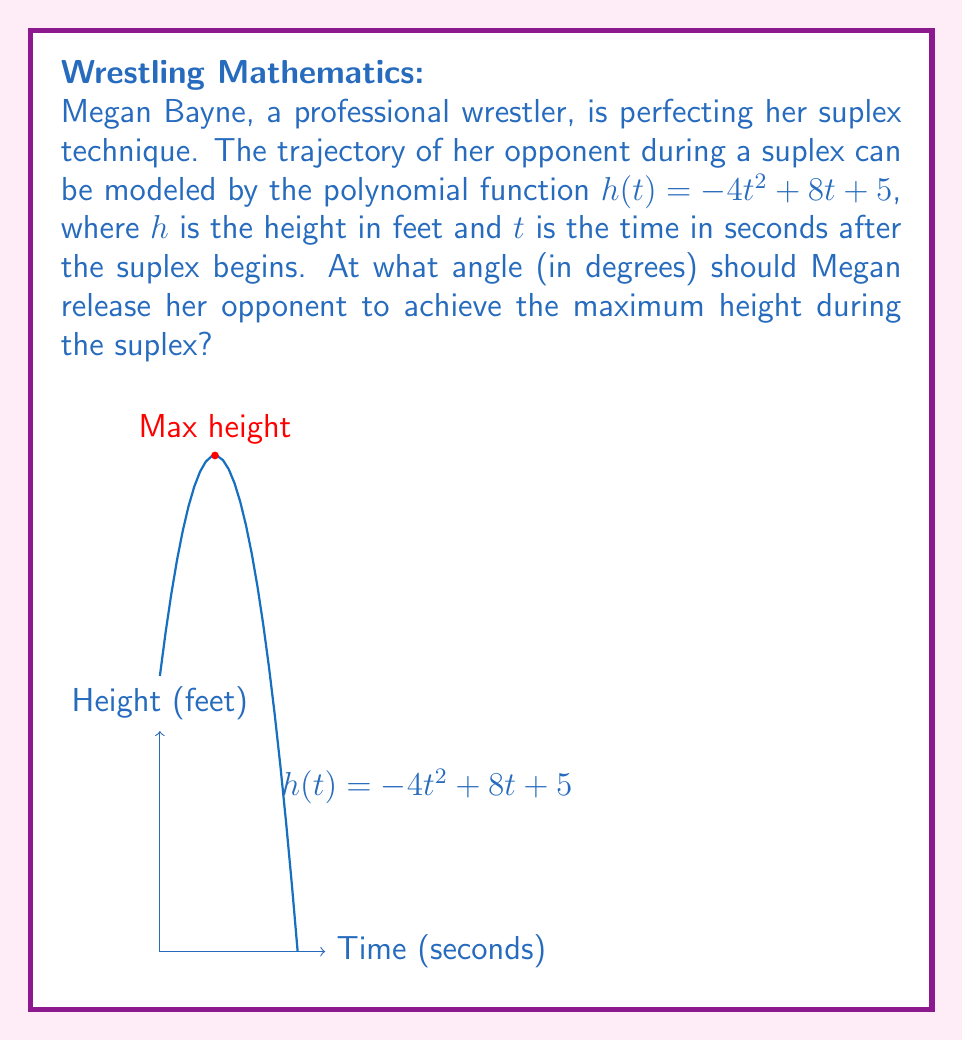Teach me how to tackle this problem. Let's approach this step-by-step:

1) To find the maximum height, we need to find the vertex of the parabola described by $h(t) = -4t^2 + 8t + 5$.

2) For a quadratic function in the form $f(x) = ax^2 + bx + c$, the x-coordinate of the vertex is given by $x = -\frac{b}{2a}$.

3) In our case, $a = -4$ and $b = 8$. So:

   $t = -\frac{8}{2(-4)} = -\frac{8}{-8} = 1$ second

4) This means the maximum height occurs 1 second after the suplex begins.

5) To find the angle, we need to use the derivative of $h(t)$ at $t = 0$, which gives us the initial velocity vector.

6) The derivative of $h(t)$ is $h'(t) = -8t + 8$.

7) At $t = 0$, $h'(0) = 8$ ft/s. This is the vertical component of the initial velocity.

8) The horizontal component of the velocity is constant in projectile motion. Let's call it $v_x$.

9) The angle $\theta$ is given by $\tan(\theta) = \frac{vertical}{horizontal} = \frac{8}{v_x}$.

10) In a perfect suplex, the wrestler aims to release the opponent at a 45° angle for maximum distance.

11) If $\theta = 45°$, then $\tan(45°) = 1 = \frac{8}{v_x}$

12) Therefore, $v_x = 8$ ft/s as well.

So, Megan should release her opponent at a 45° angle to achieve the maximum height during the suplex.
Answer: 45° 